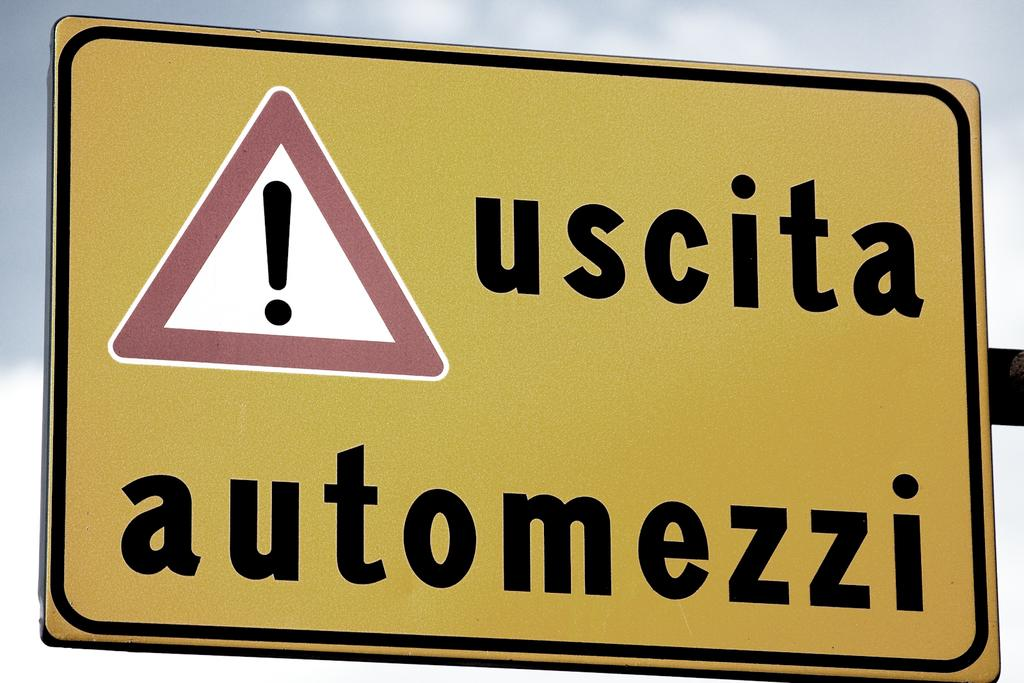<image>
Describe the image concisely. A yellow street sign with the words uscita atomezzi written on it. 